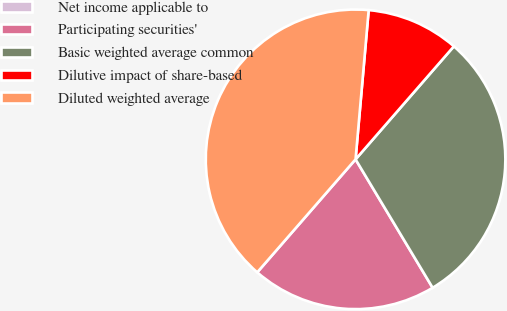<chart> <loc_0><loc_0><loc_500><loc_500><pie_chart><fcel>Net income applicable to<fcel>Participating securities'<fcel>Basic weighted average common<fcel>Dilutive impact of share-based<fcel>Diluted weighted average<nl><fcel>0.0%<fcel>20.0%<fcel>30.0%<fcel>10.0%<fcel>40.0%<nl></chart> 